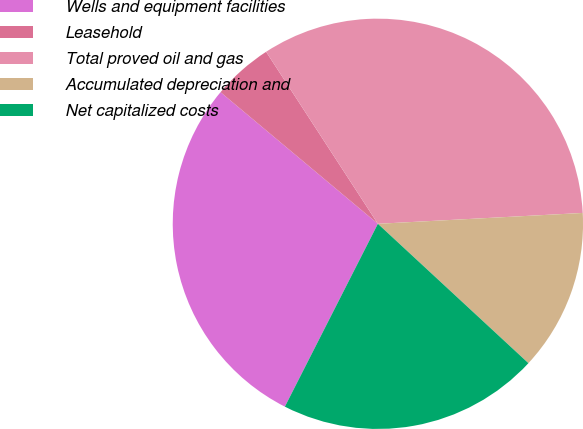Convert chart. <chart><loc_0><loc_0><loc_500><loc_500><pie_chart><fcel>Wells and equipment facilities<fcel>Leasehold<fcel>Total proved oil and gas<fcel>Accumulated depreciation and<fcel>Net capitalized costs<nl><fcel>28.6%<fcel>4.74%<fcel>33.33%<fcel>12.73%<fcel>20.6%<nl></chart> 